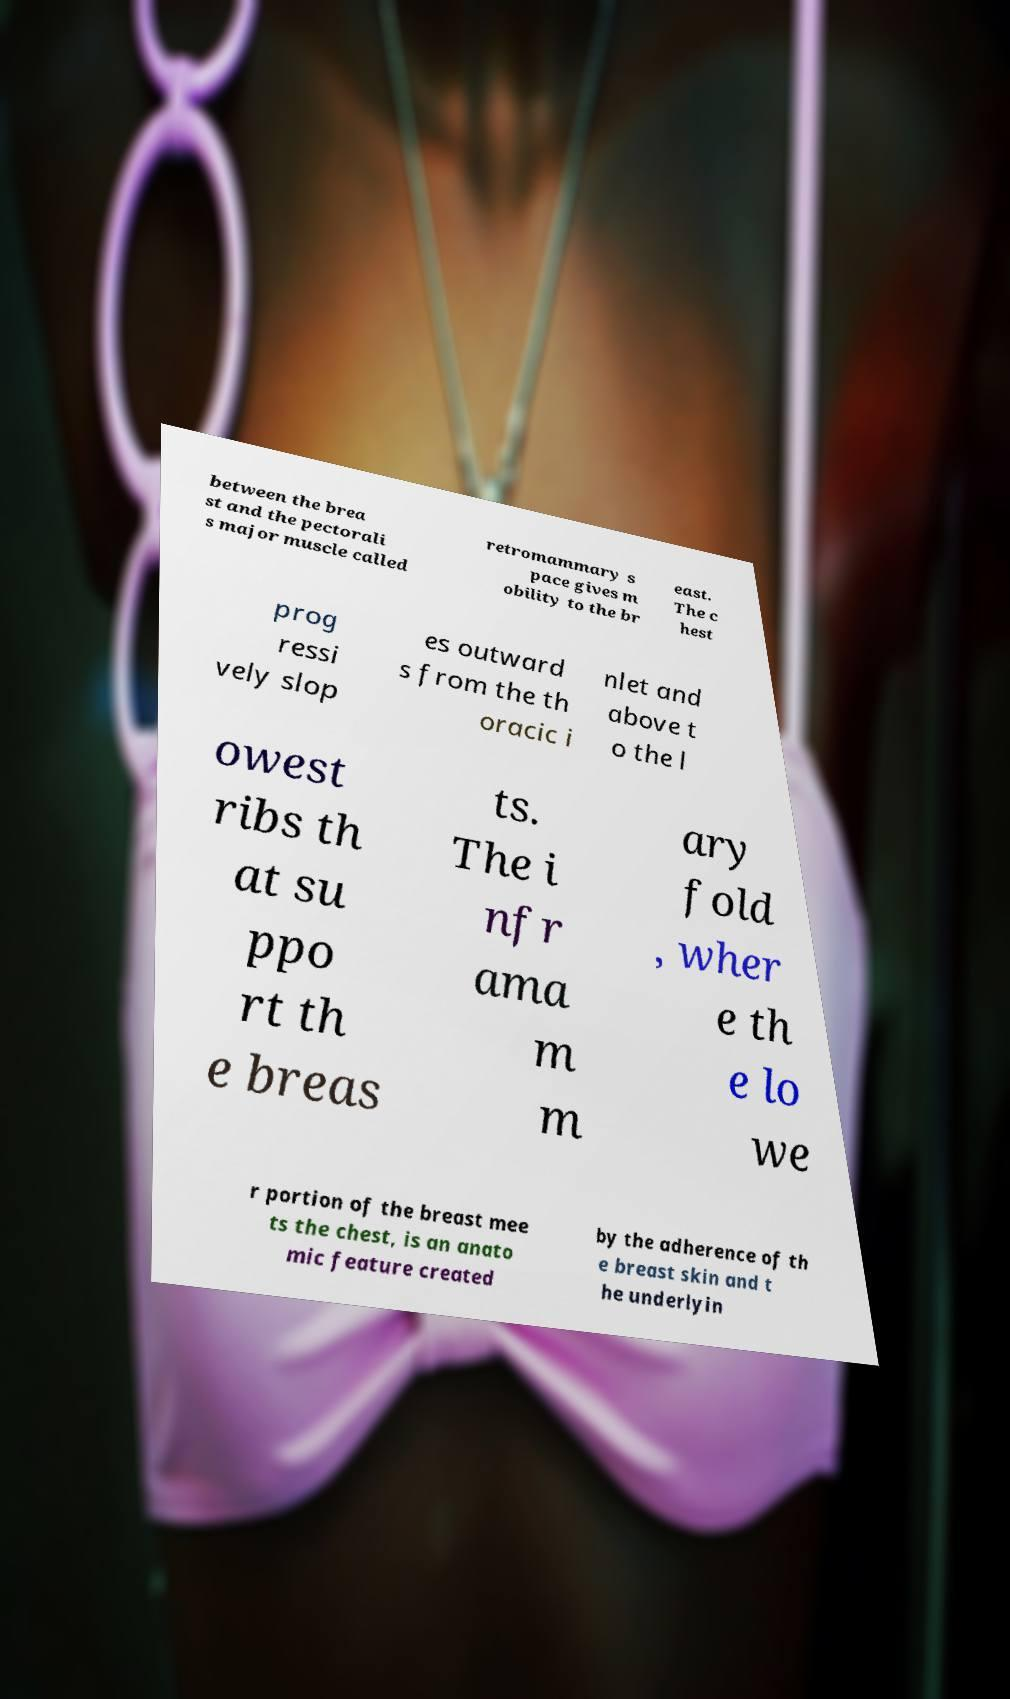There's text embedded in this image that I need extracted. Can you transcribe it verbatim? between the brea st and the pectorali s major muscle called retromammary s pace gives m obility to the br east. The c hest prog ressi vely slop es outward s from the th oracic i nlet and above t o the l owest ribs th at su ppo rt th e breas ts. The i nfr ama m m ary fold , wher e th e lo we r portion of the breast mee ts the chest, is an anato mic feature created by the adherence of th e breast skin and t he underlyin 